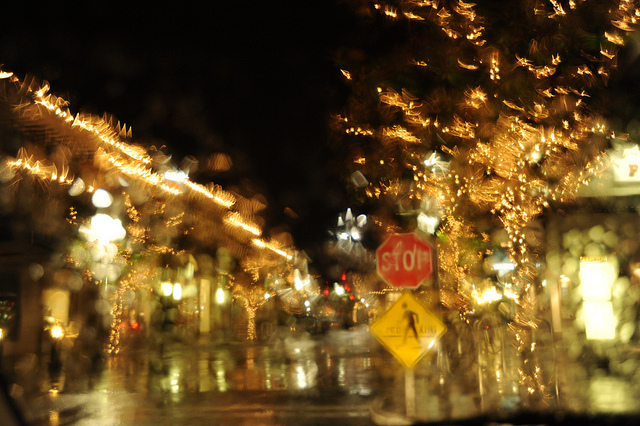Read and extract the text from this image. STOP 